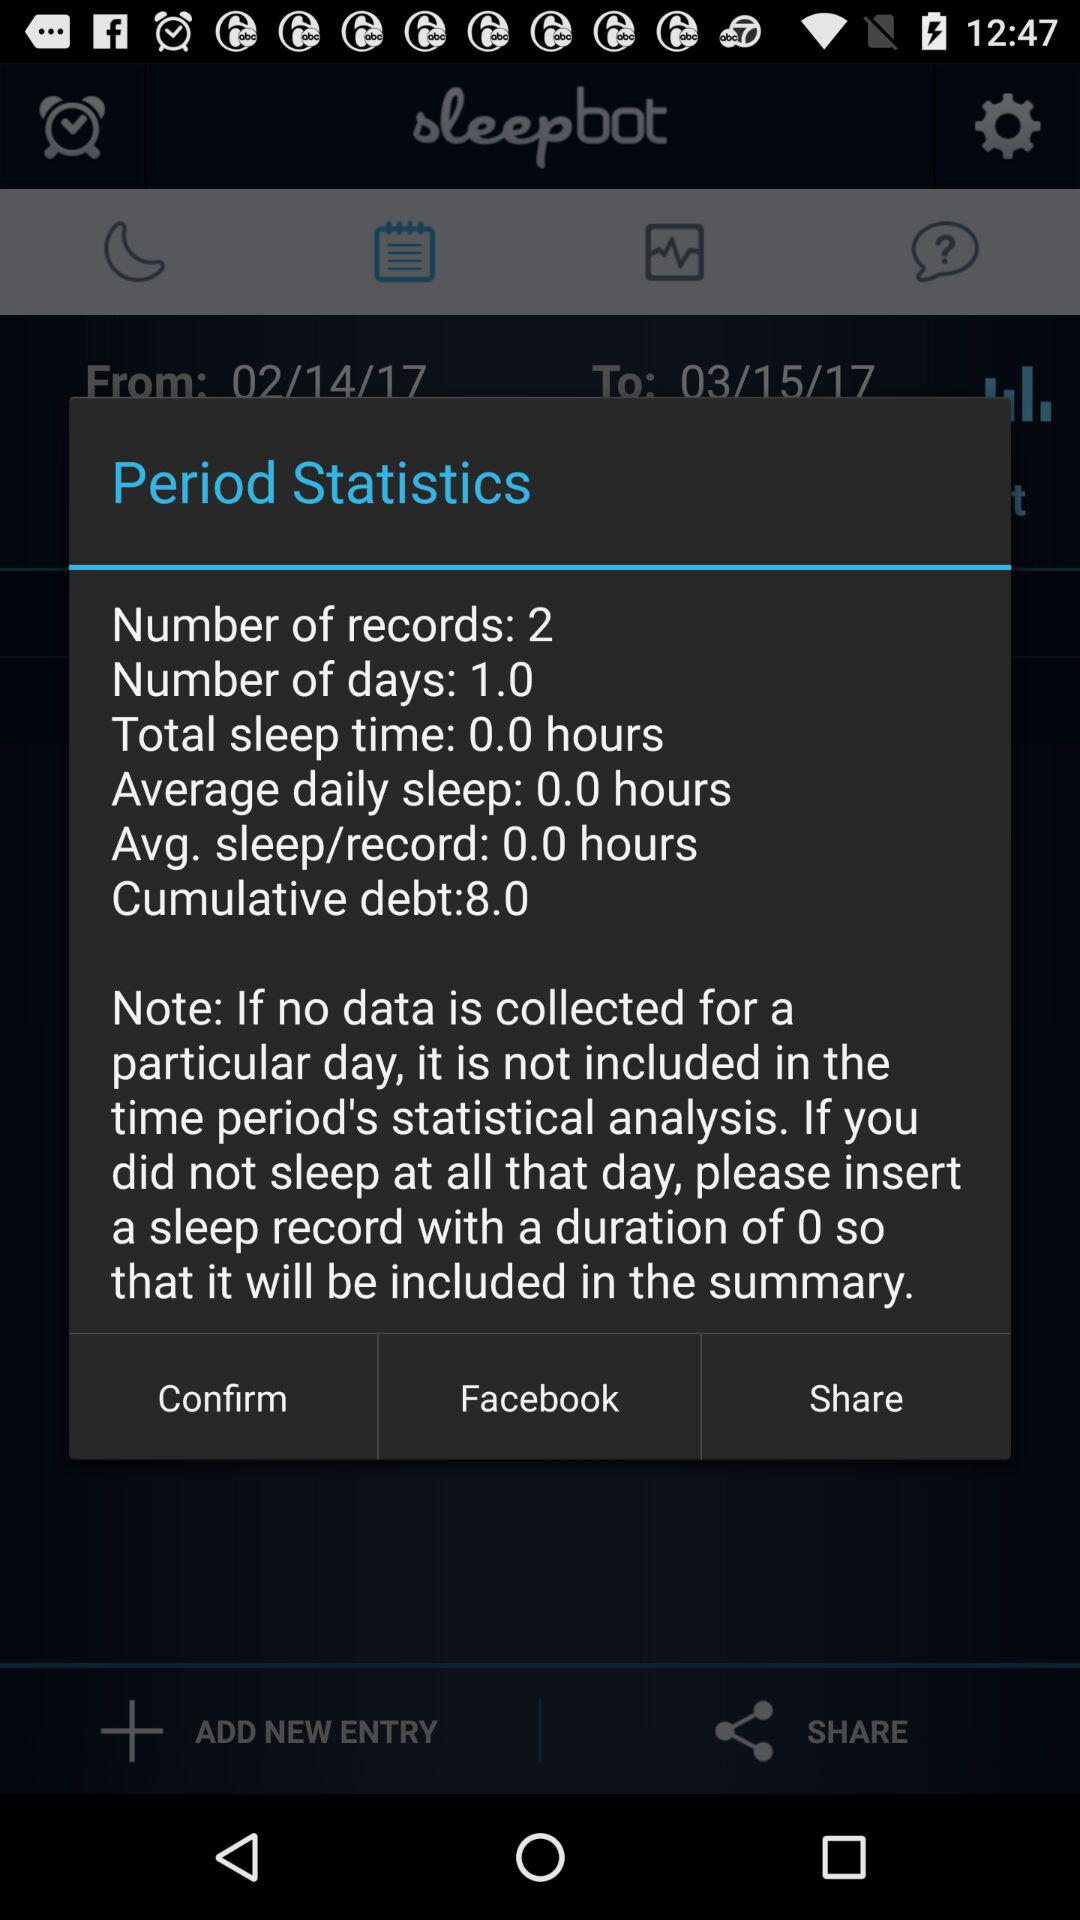How many more hours of sleep are needed to repay the cumulative debt?
Answer the question using a single word or phrase. 8.0 